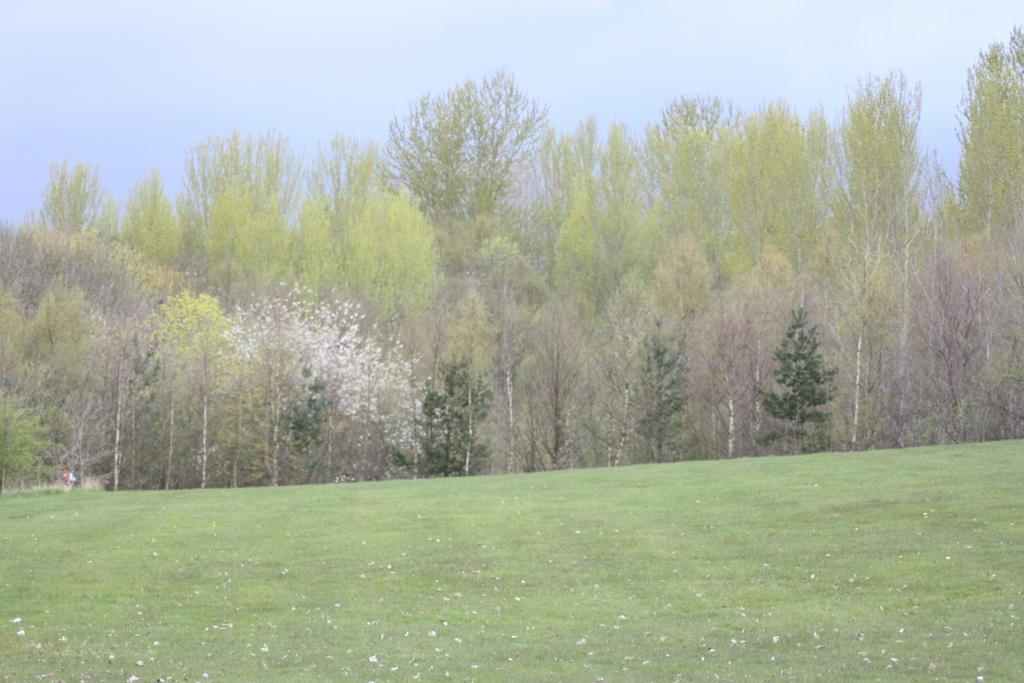What type of terrain is visible in the foreground of the image? There is grassland in the foreground of the image. What other natural elements can be seen in the image? There are trees in the middle of the image. What is visible at the top of the image? The sky is visible at the top of the image. How many friends are visible in the image? There are no friends present in the image; it features natural elements such as grassland, trees, and the sky. What type of beast can be seen roaming in the grassland in the image? There is no beast present in the image; it only features grassland, trees, and the sky. 